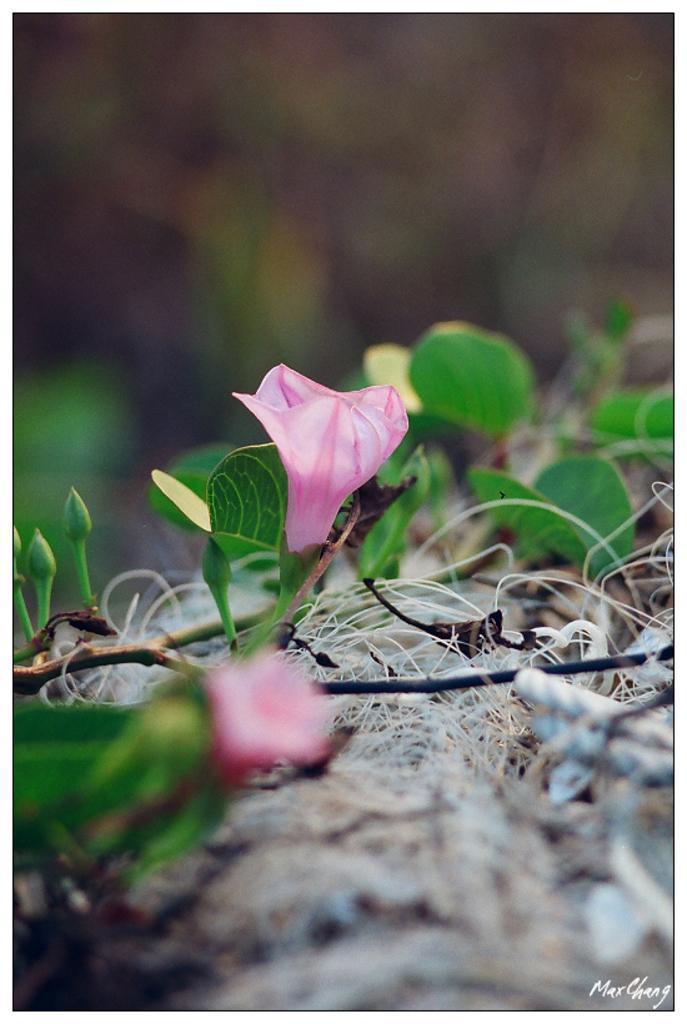How would you summarize this image in a sentence or two? In this picture I can see some flowers, buds to the plants. 